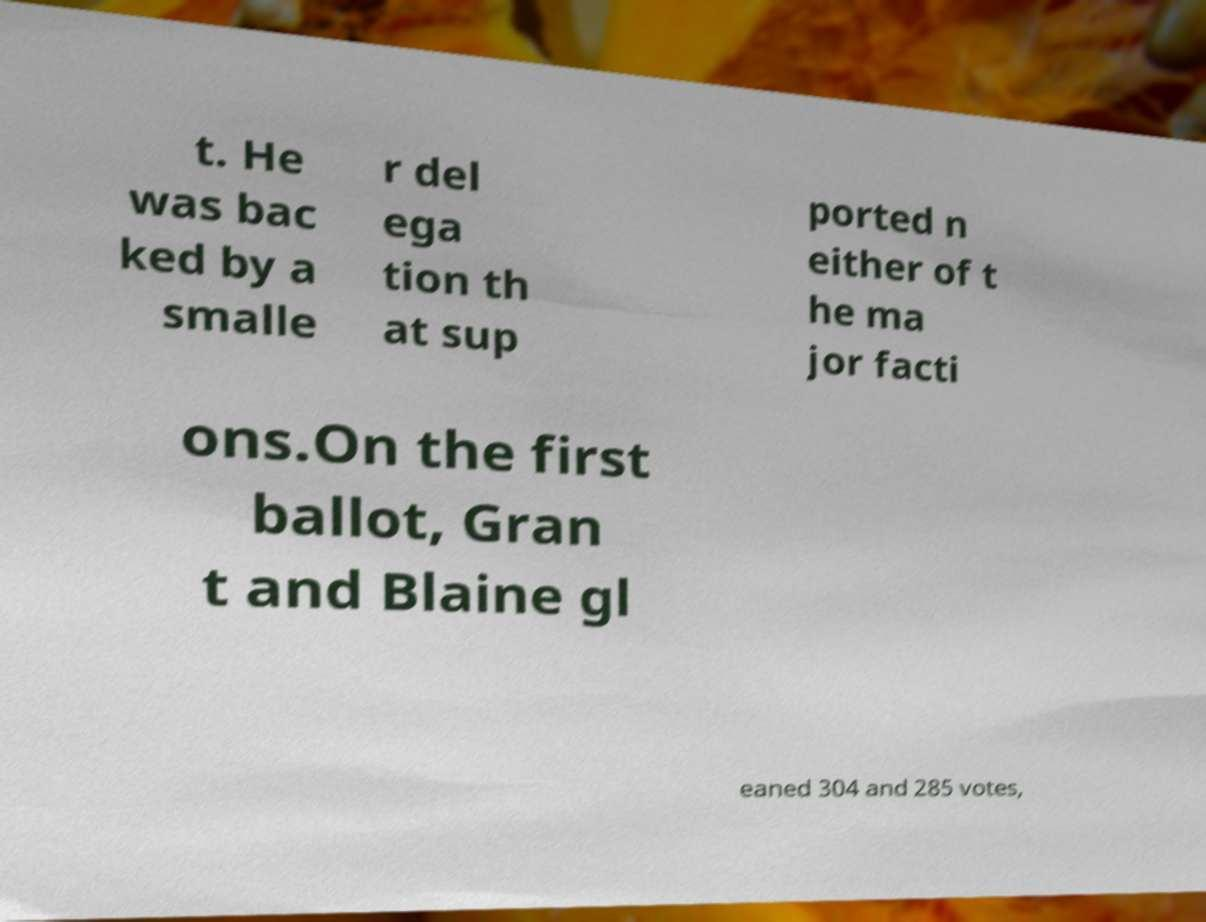What messages or text are displayed in this image? I need them in a readable, typed format. t. He was bac ked by a smalle r del ega tion th at sup ported n either of t he ma jor facti ons.On the first ballot, Gran t and Blaine gl eaned 304 and 285 votes, 